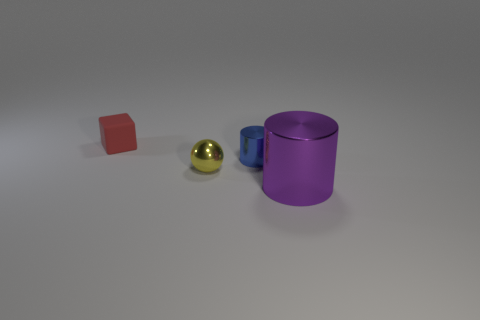Is there any other thing that has the same material as the tiny blue cylinder?
Give a very brief answer. Yes. There is a metallic object that is to the right of the shiny cylinder that is behind the large shiny thing; is there a red matte thing that is to the right of it?
Your answer should be very brief. No. What number of big objects are blue things or purple metal spheres?
Offer a very short reply. 0. Is there any other thing that has the same color as the small rubber object?
Offer a terse response. No. There is a metal cylinder that is left of the purple metallic thing; does it have the same size as the small rubber object?
Provide a short and direct response. Yes. What color is the small object to the left of the small metallic object to the left of the cylinder on the left side of the big purple thing?
Your response must be concise. Red. The small cylinder is what color?
Keep it short and to the point. Blue. Does the tiny cube have the same color as the small metal cylinder?
Your answer should be very brief. No. Are the cylinder behind the large purple object and the cylinder that is in front of the small metallic sphere made of the same material?
Ensure brevity in your answer.  Yes. There is another tiny object that is the same shape as the purple object; what is its material?
Offer a terse response. Metal. 